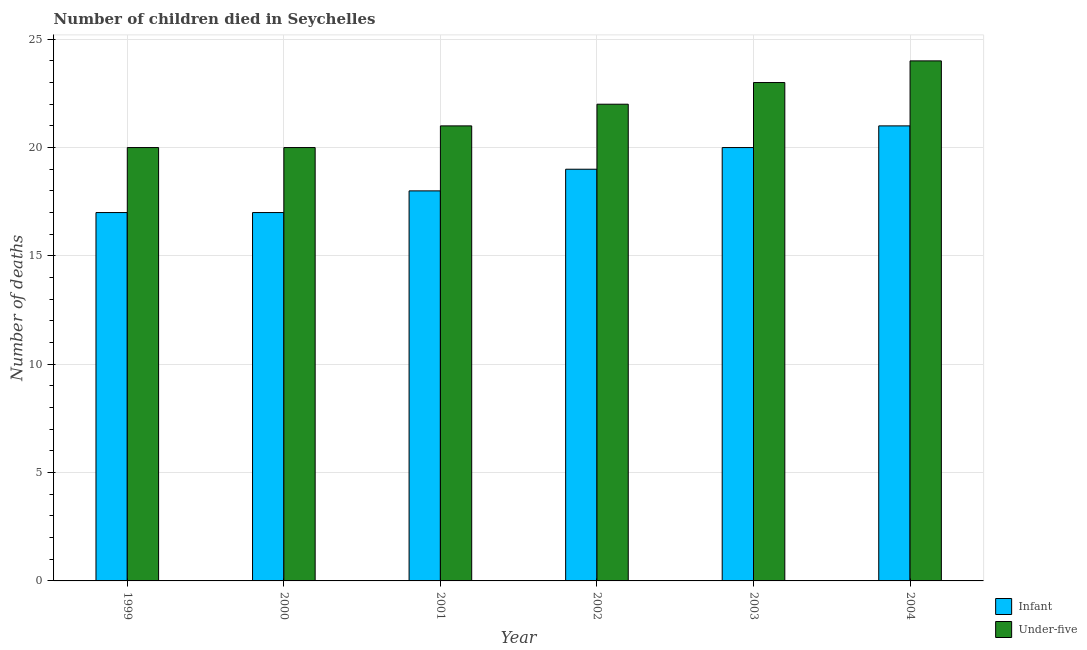How many different coloured bars are there?
Ensure brevity in your answer.  2. Are the number of bars per tick equal to the number of legend labels?
Provide a short and direct response. Yes. Are the number of bars on each tick of the X-axis equal?
Your response must be concise. Yes. How many bars are there on the 4th tick from the left?
Offer a terse response. 2. What is the label of the 1st group of bars from the left?
Give a very brief answer. 1999. What is the number of under-five deaths in 2003?
Ensure brevity in your answer.  23. Across all years, what is the maximum number of infant deaths?
Keep it short and to the point. 21. Across all years, what is the minimum number of under-five deaths?
Provide a short and direct response. 20. In which year was the number of under-five deaths minimum?
Keep it short and to the point. 1999. What is the total number of infant deaths in the graph?
Your answer should be compact. 112. What is the difference between the number of under-five deaths in 1999 and that in 2000?
Offer a very short reply. 0. What is the difference between the number of infant deaths in 2001 and the number of under-five deaths in 2004?
Ensure brevity in your answer.  -3. What is the average number of under-five deaths per year?
Give a very brief answer. 21.67. What is the ratio of the number of infant deaths in 2000 to that in 2002?
Keep it short and to the point. 0.89. What is the difference between the highest and the lowest number of infant deaths?
Ensure brevity in your answer.  4. In how many years, is the number of under-five deaths greater than the average number of under-five deaths taken over all years?
Provide a short and direct response. 3. Is the sum of the number of under-five deaths in 2001 and 2003 greater than the maximum number of infant deaths across all years?
Make the answer very short. Yes. What does the 2nd bar from the left in 2002 represents?
Keep it short and to the point. Under-five. What does the 1st bar from the right in 2004 represents?
Your answer should be very brief. Under-five. How many bars are there?
Keep it short and to the point. 12. What is the difference between two consecutive major ticks on the Y-axis?
Provide a succinct answer. 5. Are the values on the major ticks of Y-axis written in scientific E-notation?
Offer a terse response. No. Does the graph contain grids?
Provide a succinct answer. Yes. Where does the legend appear in the graph?
Provide a succinct answer. Bottom right. How many legend labels are there?
Your response must be concise. 2. How are the legend labels stacked?
Your answer should be compact. Vertical. What is the title of the graph?
Ensure brevity in your answer.  Number of children died in Seychelles. Does "Food" appear as one of the legend labels in the graph?
Give a very brief answer. No. What is the label or title of the Y-axis?
Give a very brief answer. Number of deaths. What is the Number of deaths of Infant in 1999?
Offer a terse response. 17. What is the Number of deaths of Infant in 2000?
Your answer should be compact. 17. What is the Number of deaths of Under-five in 2000?
Offer a very short reply. 20. What is the Number of deaths in Under-five in 2001?
Make the answer very short. 21. What is the Number of deaths in Under-five in 2002?
Give a very brief answer. 22. What is the Number of deaths in Infant in 2003?
Keep it short and to the point. 20. What is the Number of deaths of Under-five in 2004?
Your response must be concise. 24. Across all years, what is the maximum Number of deaths of Infant?
Ensure brevity in your answer.  21. Across all years, what is the minimum Number of deaths in Infant?
Provide a succinct answer. 17. Across all years, what is the minimum Number of deaths of Under-five?
Your answer should be compact. 20. What is the total Number of deaths of Infant in the graph?
Provide a short and direct response. 112. What is the total Number of deaths of Under-five in the graph?
Your answer should be very brief. 130. What is the difference between the Number of deaths of Infant in 1999 and that in 2000?
Offer a terse response. 0. What is the difference between the Number of deaths of Under-five in 1999 and that in 2000?
Give a very brief answer. 0. What is the difference between the Number of deaths in Infant in 1999 and that in 2001?
Ensure brevity in your answer.  -1. What is the difference between the Number of deaths of Infant in 1999 and that in 2002?
Provide a short and direct response. -2. What is the difference between the Number of deaths in Under-five in 1999 and that in 2002?
Provide a succinct answer. -2. What is the difference between the Number of deaths of Infant in 1999 and that in 2003?
Ensure brevity in your answer.  -3. What is the difference between the Number of deaths in Under-five in 1999 and that in 2003?
Provide a succinct answer. -3. What is the difference between the Number of deaths in Under-five in 1999 and that in 2004?
Provide a succinct answer. -4. What is the difference between the Number of deaths in Infant in 2000 and that in 2001?
Keep it short and to the point. -1. What is the difference between the Number of deaths in Under-five in 2000 and that in 2001?
Keep it short and to the point. -1. What is the difference between the Number of deaths of Infant in 2000 and that in 2002?
Your answer should be compact. -2. What is the difference between the Number of deaths of Under-five in 2000 and that in 2002?
Give a very brief answer. -2. What is the difference between the Number of deaths in Infant in 2000 and that in 2003?
Make the answer very short. -3. What is the difference between the Number of deaths in Under-five in 2000 and that in 2003?
Your answer should be very brief. -3. What is the difference between the Number of deaths in Infant in 2000 and that in 2004?
Your answer should be very brief. -4. What is the difference between the Number of deaths of Infant in 2001 and that in 2002?
Give a very brief answer. -1. What is the difference between the Number of deaths of Under-five in 2001 and that in 2002?
Ensure brevity in your answer.  -1. What is the difference between the Number of deaths of Under-five in 2001 and that in 2004?
Provide a short and direct response. -3. What is the difference between the Number of deaths in Infant in 2002 and that in 2004?
Your answer should be very brief. -2. What is the difference between the Number of deaths in Under-five in 2003 and that in 2004?
Your answer should be very brief. -1. What is the difference between the Number of deaths of Infant in 1999 and the Number of deaths of Under-five in 2000?
Provide a short and direct response. -3. What is the difference between the Number of deaths of Infant in 1999 and the Number of deaths of Under-five in 2001?
Make the answer very short. -4. What is the difference between the Number of deaths in Infant in 2000 and the Number of deaths in Under-five in 2001?
Ensure brevity in your answer.  -4. What is the difference between the Number of deaths in Infant in 2000 and the Number of deaths in Under-five in 2002?
Your answer should be compact. -5. What is the difference between the Number of deaths in Infant in 2000 and the Number of deaths in Under-five in 2003?
Ensure brevity in your answer.  -6. What is the difference between the Number of deaths of Infant in 2001 and the Number of deaths of Under-five in 2002?
Provide a short and direct response. -4. What is the difference between the Number of deaths of Infant in 2001 and the Number of deaths of Under-five in 2003?
Keep it short and to the point. -5. What is the difference between the Number of deaths in Infant in 2002 and the Number of deaths in Under-five in 2004?
Provide a short and direct response. -5. What is the average Number of deaths of Infant per year?
Your response must be concise. 18.67. What is the average Number of deaths in Under-five per year?
Give a very brief answer. 21.67. In the year 2000, what is the difference between the Number of deaths in Infant and Number of deaths in Under-five?
Ensure brevity in your answer.  -3. In the year 2002, what is the difference between the Number of deaths of Infant and Number of deaths of Under-five?
Your answer should be compact. -3. In the year 2003, what is the difference between the Number of deaths in Infant and Number of deaths in Under-five?
Ensure brevity in your answer.  -3. What is the ratio of the Number of deaths in Infant in 1999 to that in 2000?
Provide a succinct answer. 1. What is the ratio of the Number of deaths of Under-five in 1999 to that in 2000?
Your response must be concise. 1. What is the ratio of the Number of deaths in Infant in 1999 to that in 2002?
Your answer should be compact. 0.89. What is the ratio of the Number of deaths of Under-five in 1999 to that in 2002?
Keep it short and to the point. 0.91. What is the ratio of the Number of deaths of Infant in 1999 to that in 2003?
Give a very brief answer. 0.85. What is the ratio of the Number of deaths in Under-five in 1999 to that in 2003?
Your answer should be compact. 0.87. What is the ratio of the Number of deaths in Infant in 1999 to that in 2004?
Make the answer very short. 0.81. What is the ratio of the Number of deaths of Under-five in 1999 to that in 2004?
Offer a very short reply. 0.83. What is the ratio of the Number of deaths of Under-five in 2000 to that in 2001?
Provide a succinct answer. 0.95. What is the ratio of the Number of deaths in Infant in 2000 to that in 2002?
Provide a succinct answer. 0.89. What is the ratio of the Number of deaths of Under-five in 2000 to that in 2002?
Offer a very short reply. 0.91. What is the ratio of the Number of deaths in Under-five in 2000 to that in 2003?
Offer a very short reply. 0.87. What is the ratio of the Number of deaths in Infant in 2000 to that in 2004?
Give a very brief answer. 0.81. What is the ratio of the Number of deaths in Under-five in 2000 to that in 2004?
Provide a short and direct response. 0.83. What is the ratio of the Number of deaths in Under-five in 2001 to that in 2002?
Offer a very short reply. 0.95. What is the ratio of the Number of deaths in Infant in 2001 to that in 2003?
Provide a succinct answer. 0.9. What is the ratio of the Number of deaths of Under-five in 2001 to that in 2003?
Your response must be concise. 0.91. What is the ratio of the Number of deaths in Under-five in 2001 to that in 2004?
Ensure brevity in your answer.  0.88. What is the ratio of the Number of deaths in Under-five in 2002 to that in 2003?
Give a very brief answer. 0.96. What is the ratio of the Number of deaths in Infant in 2002 to that in 2004?
Provide a short and direct response. 0.9. What is the ratio of the Number of deaths in Infant in 2003 to that in 2004?
Ensure brevity in your answer.  0.95. What is the difference between the highest and the second highest Number of deaths in Infant?
Give a very brief answer. 1. What is the difference between the highest and the lowest Number of deaths in Infant?
Your answer should be compact. 4. What is the difference between the highest and the lowest Number of deaths of Under-five?
Keep it short and to the point. 4. 